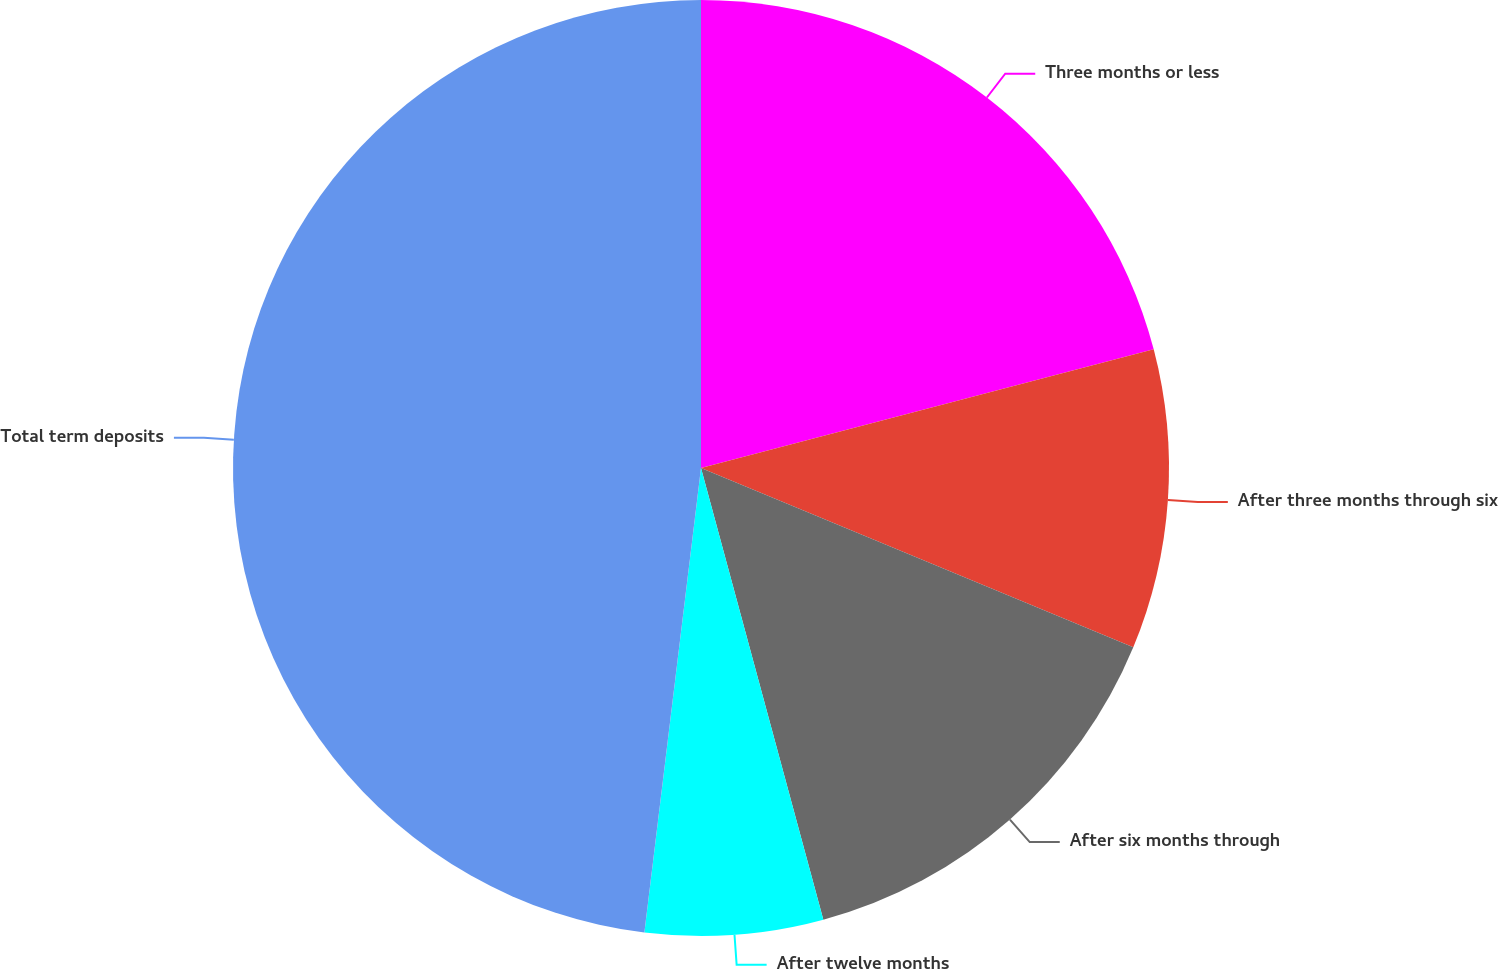Convert chart to OTSL. <chart><loc_0><loc_0><loc_500><loc_500><pie_chart><fcel>Three months or less<fcel>After three months through six<fcel>After six months through<fcel>After twelve months<fcel>Total term deposits<nl><fcel>20.92%<fcel>10.34%<fcel>14.53%<fcel>6.14%<fcel>48.07%<nl></chart> 